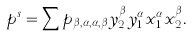<formula> <loc_0><loc_0><loc_500><loc_500>p ^ { s } = \sum p _ { \beta , \alpha , \alpha , \beta } y _ { 2 } ^ { \beta } y _ { 1 } ^ { \alpha } x _ { 1 } ^ { \alpha } x _ { 2 } ^ { \beta } .</formula> 